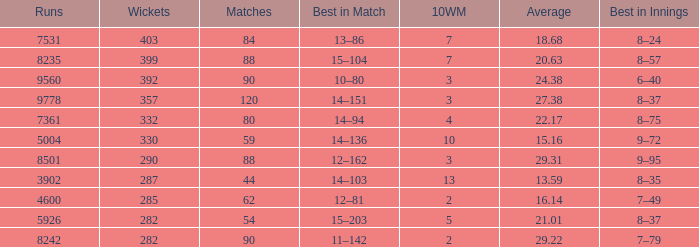What is the total number of wickets that have runs under 4600 and matches under 44? None. 